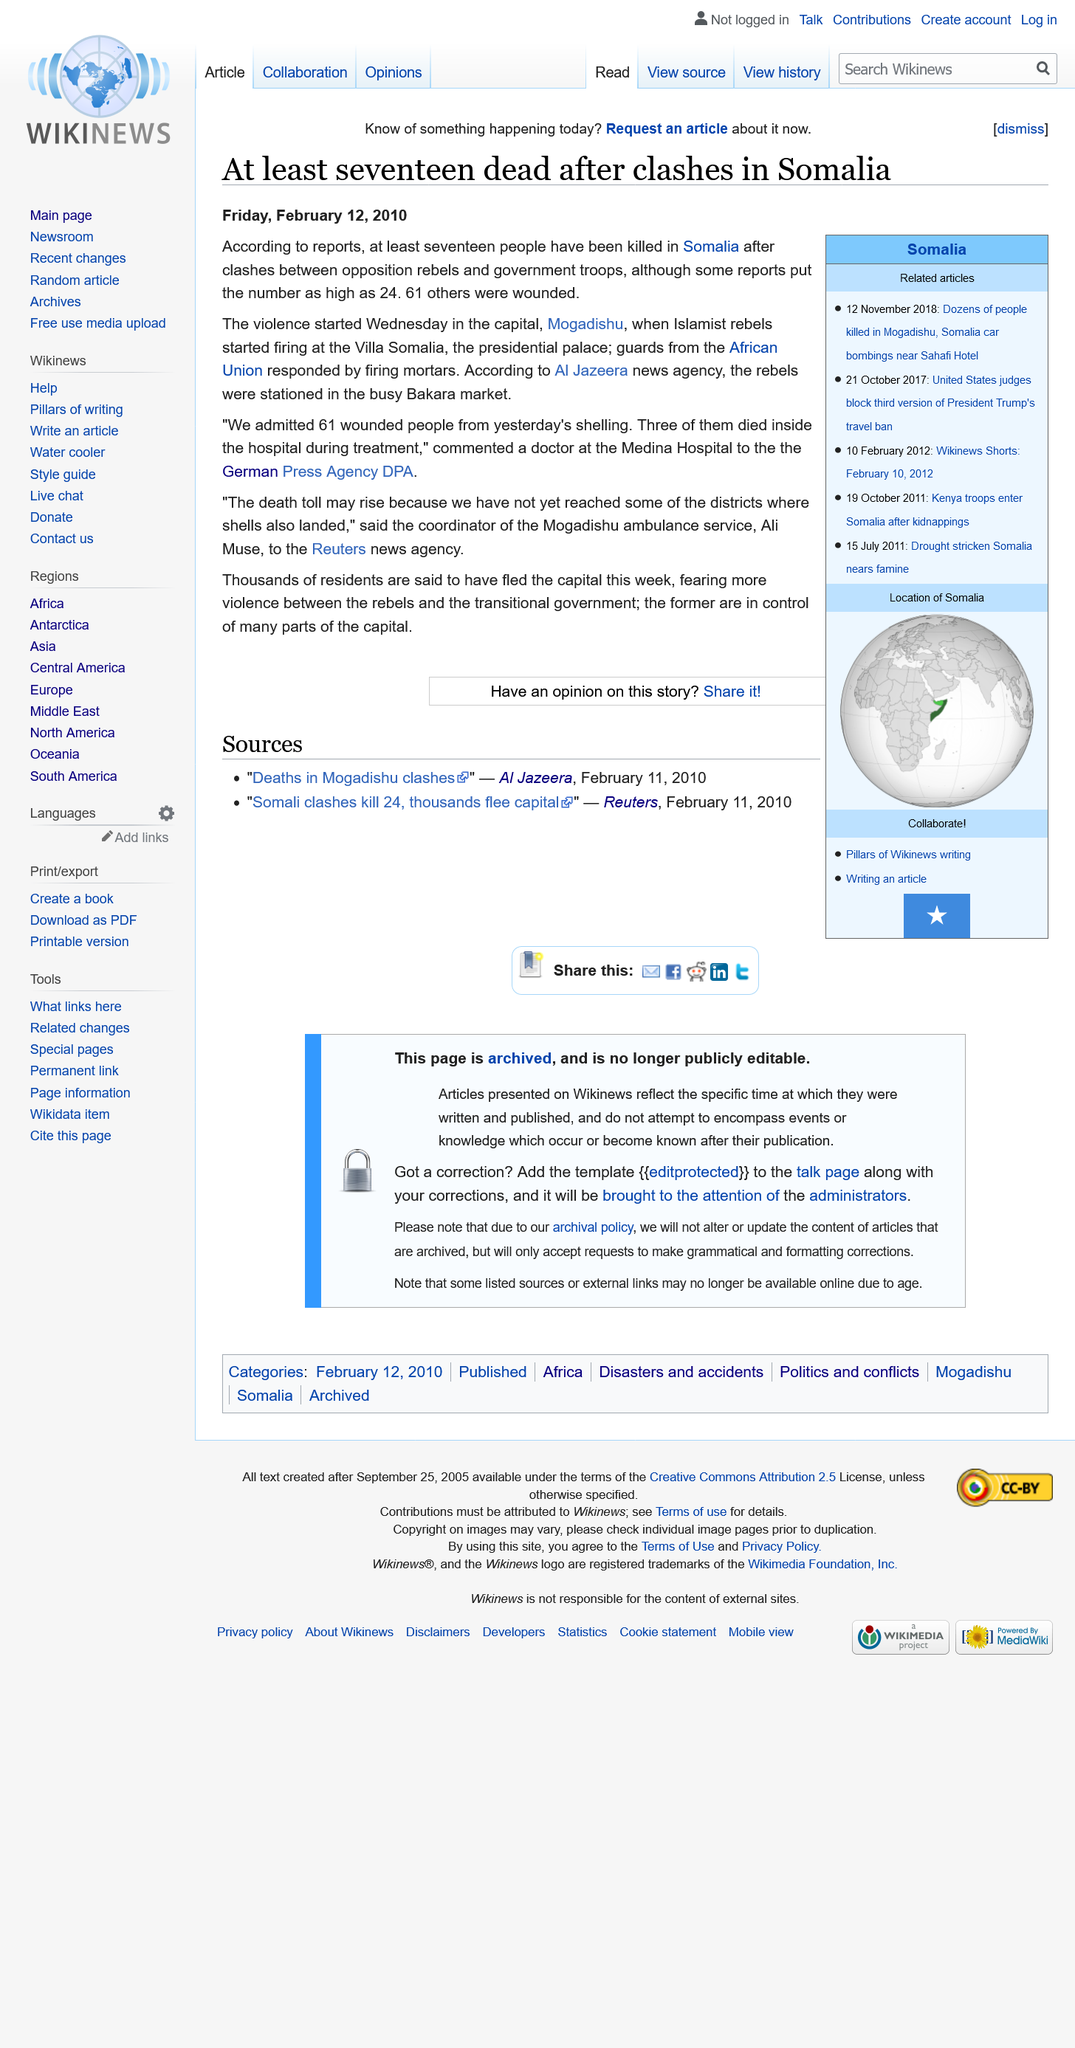Identify some key points in this picture. A total of 61 wounded individuals were admitted to the Medina Hospital. The violence in Mogadishu, Somalia was the starting point of the violence. The coordinator of the Mogadishu ambulance service is named Ali Muse. 